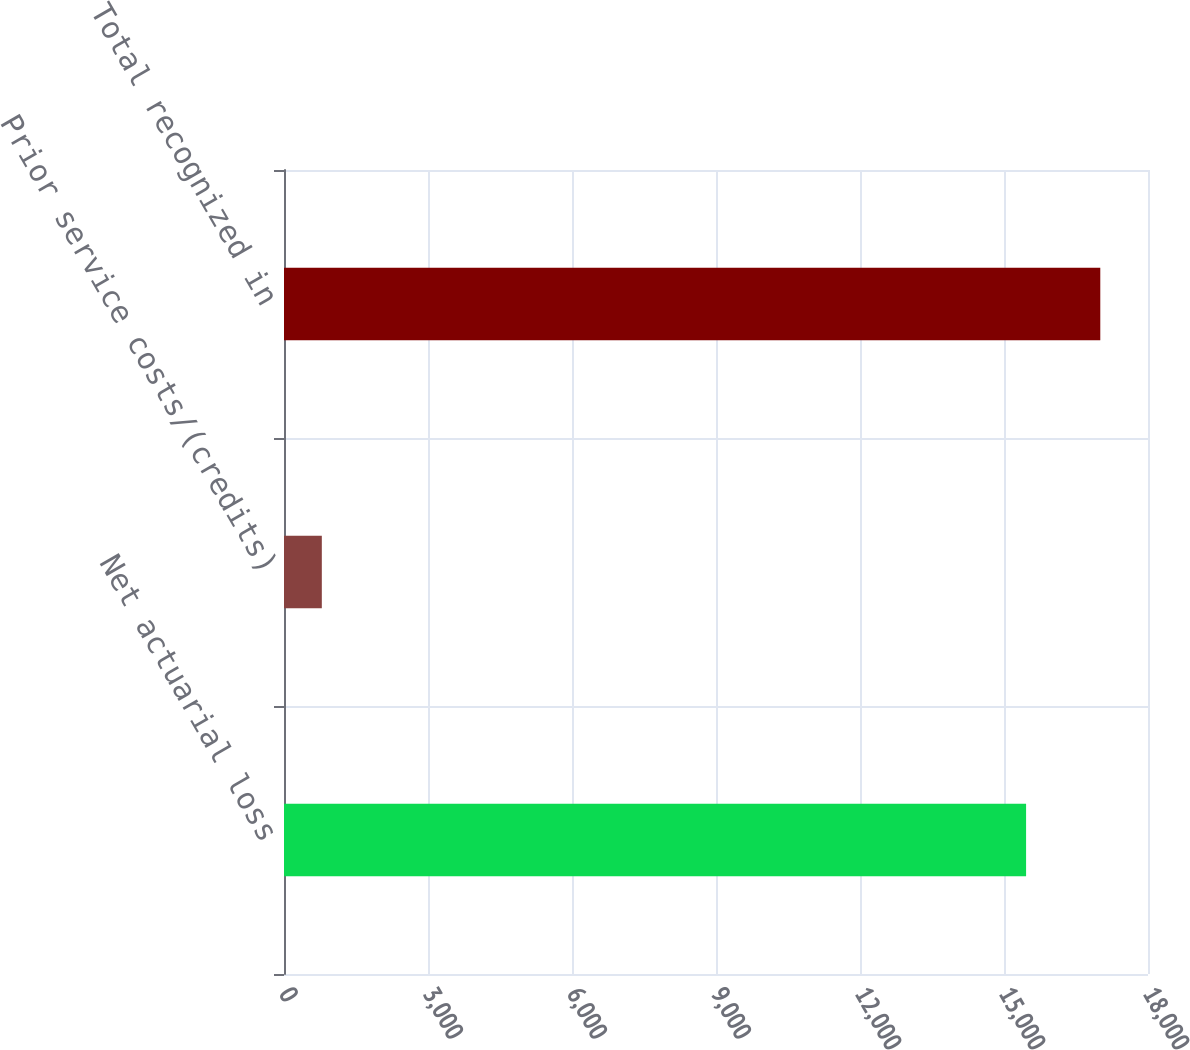<chart> <loc_0><loc_0><loc_500><loc_500><bar_chart><fcel>Net actuarial loss<fcel>Prior service costs/(credits)<fcel>Total recognized in<nl><fcel>15460<fcel>788<fcel>17006<nl></chart> 